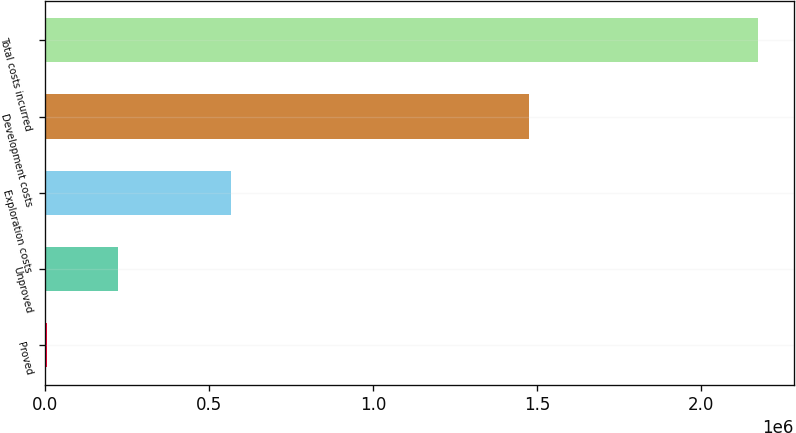Convert chart to OTSL. <chart><loc_0><loc_0><loc_500><loc_500><bar_chart><fcel>Proved<fcel>Unproved<fcel>Exploration costs<fcel>Development costs<fcel>Total costs incurred<nl><fcel>7571<fcel>224162<fcel>567196<fcel>1.47439e+06<fcel>2.17349e+06<nl></chart> 